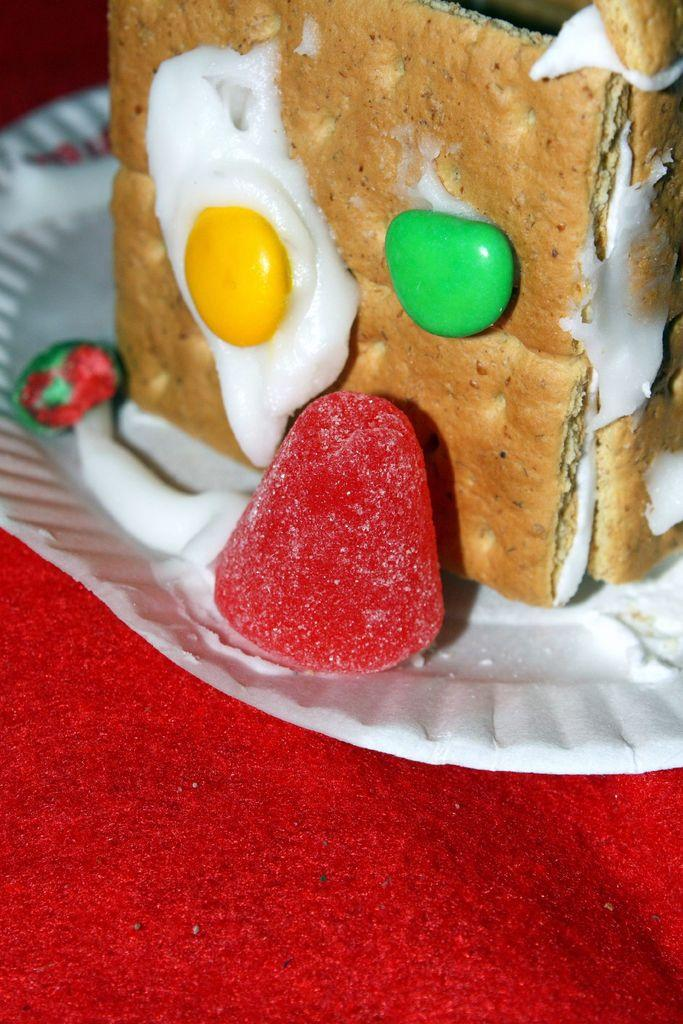What color is the cloth in the image? The cloth in the image is red. What is placed on the red cloth? There is a white plate on the red cloth. What is on the white plate? There are pastries on the white plate. What else is present near the plate? There is red candy beside the plate. What type of suit is being adjusted in the image? There is no suit or adjustment present in the image; it features a red cloth, a white plate with pastries, and red candy. What is the mass of the pastries on the plate? The mass of the pastries cannot be determined from the image alone, as it does not provide any information about their size or weight. 